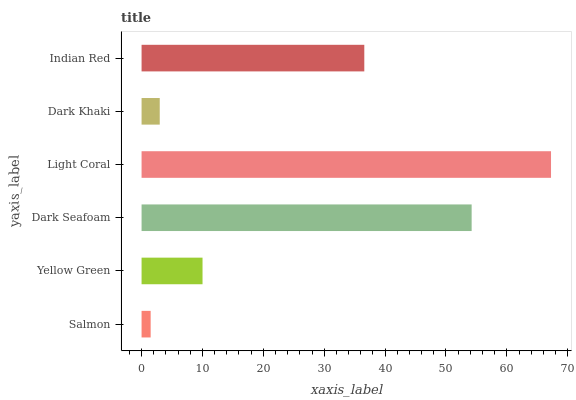Is Salmon the minimum?
Answer yes or no. Yes. Is Light Coral the maximum?
Answer yes or no. Yes. Is Yellow Green the minimum?
Answer yes or no. No. Is Yellow Green the maximum?
Answer yes or no. No. Is Yellow Green greater than Salmon?
Answer yes or no. Yes. Is Salmon less than Yellow Green?
Answer yes or no. Yes. Is Salmon greater than Yellow Green?
Answer yes or no. No. Is Yellow Green less than Salmon?
Answer yes or no. No. Is Indian Red the high median?
Answer yes or no. Yes. Is Yellow Green the low median?
Answer yes or no. Yes. Is Dark Khaki the high median?
Answer yes or no. No. Is Light Coral the low median?
Answer yes or no. No. 